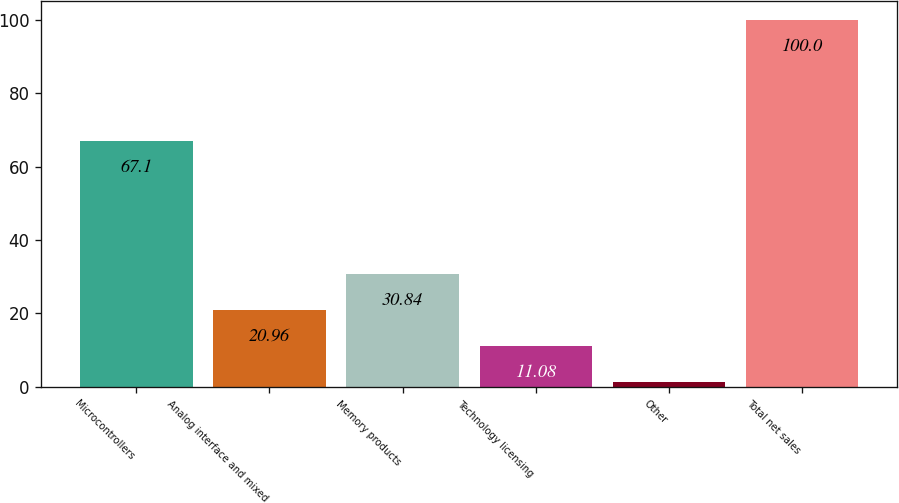Convert chart to OTSL. <chart><loc_0><loc_0><loc_500><loc_500><bar_chart><fcel>Microcontrollers<fcel>Analog interface and mixed<fcel>Memory products<fcel>Technology licensing<fcel>Other<fcel>Total net sales<nl><fcel>67.1<fcel>20.96<fcel>30.84<fcel>11.08<fcel>1.2<fcel>100<nl></chart> 